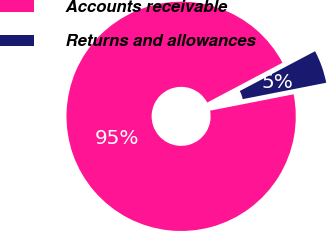Convert chart. <chart><loc_0><loc_0><loc_500><loc_500><pie_chart><fcel>Accounts receivable<fcel>Returns and allowances<nl><fcel>95.34%<fcel>4.66%<nl></chart> 